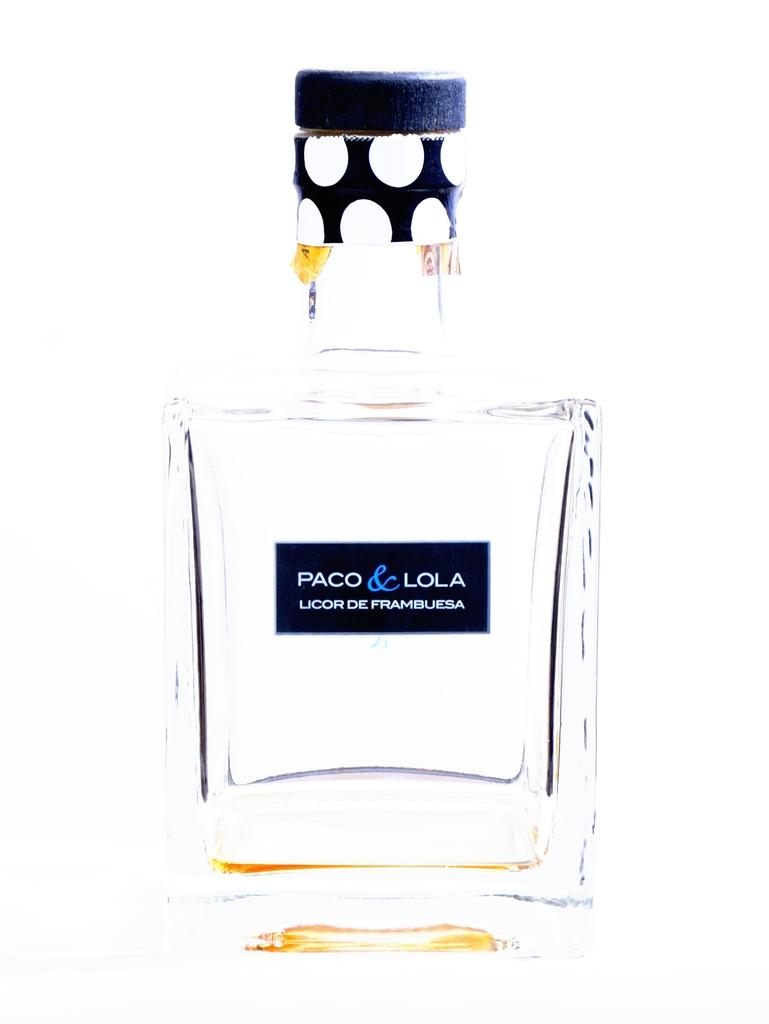<image>
Offer a succinct explanation of the picture presented. A clear bottles is labeled Paco & Lola Licor De Framblesa. 